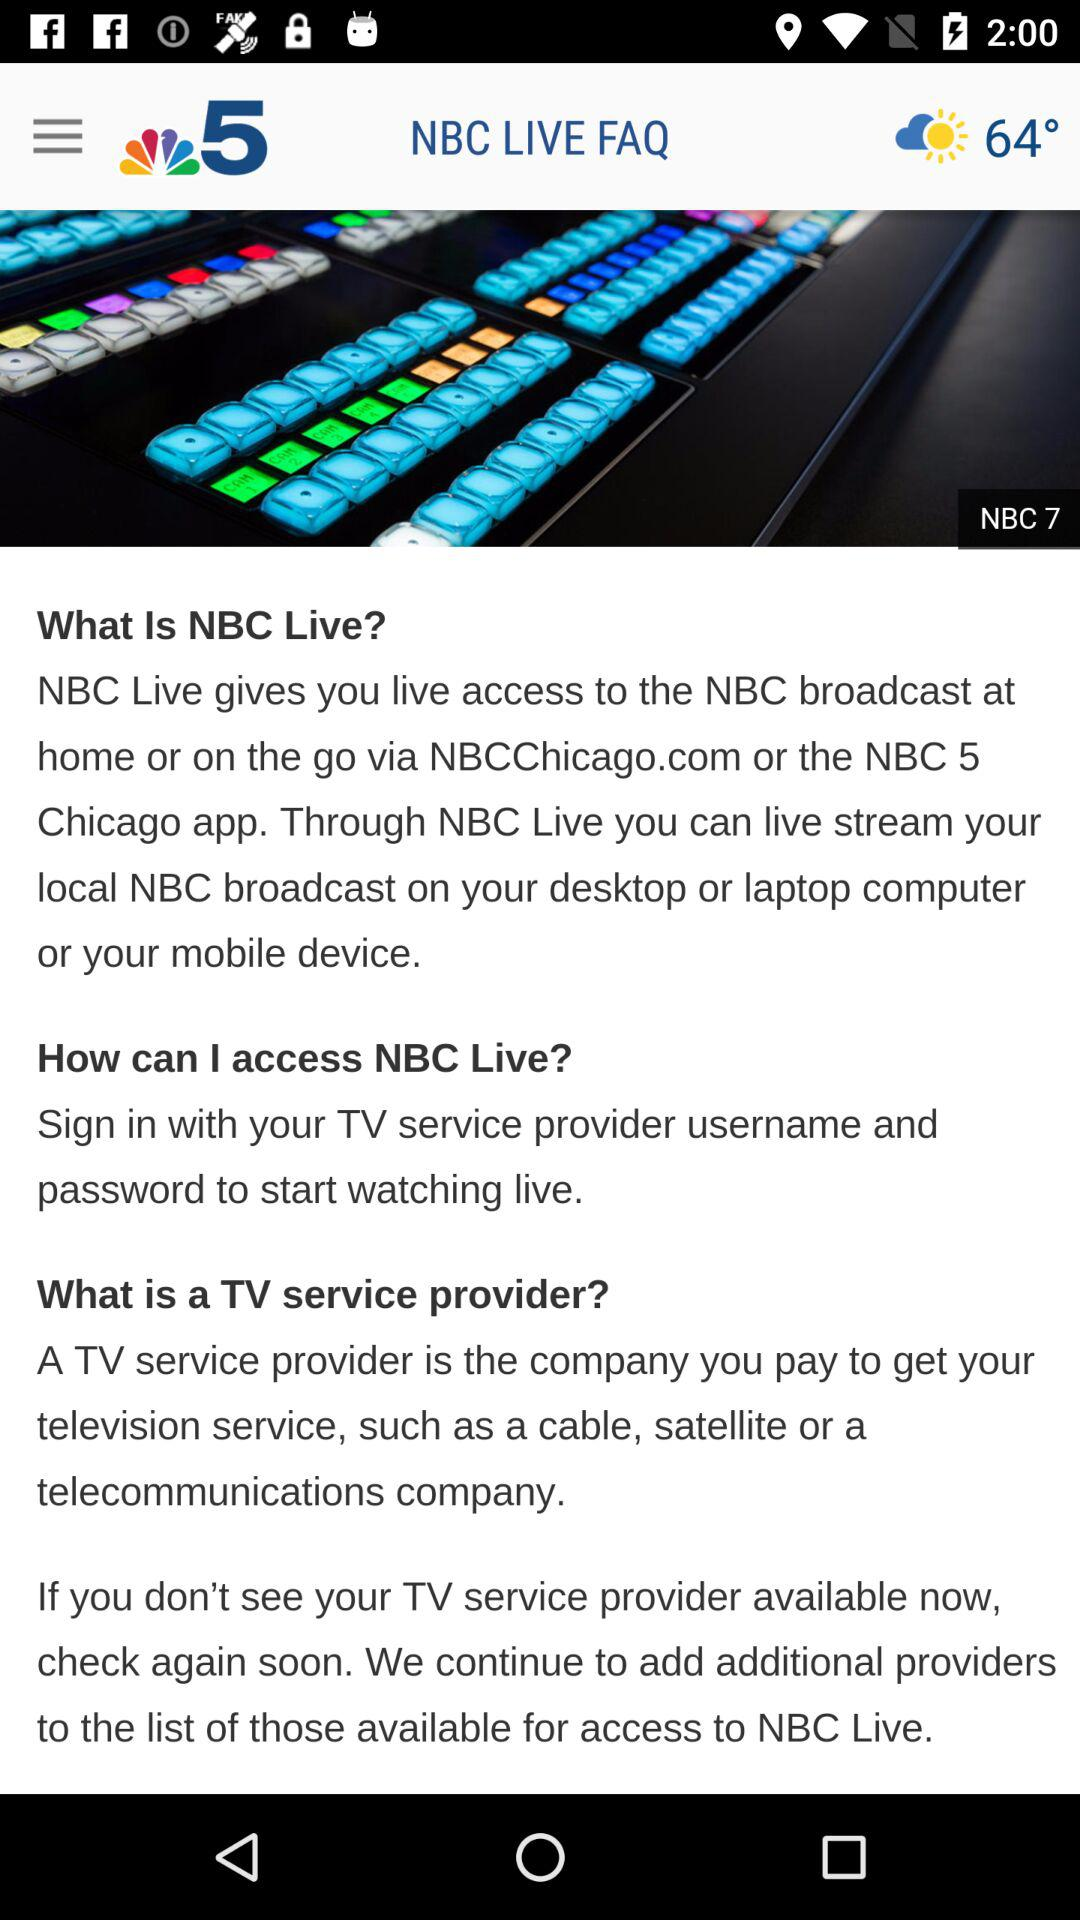What is the weather and temperature? The weather is partly sunny and the temperature is 64 degrees. 